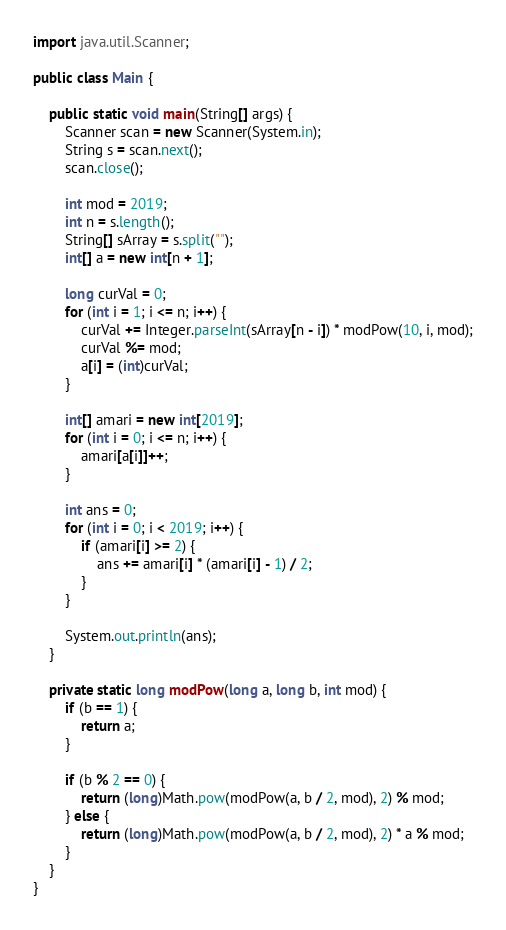Convert code to text. <code><loc_0><loc_0><loc_500><loc_500><_Java_>
import java.util.Scanner;

public class Main {

    public static void main(String[] args) {
        Scanner scan = new Scanner(System.in);
        String s = scan.next();
        scan.close();

        int mod = 2019;
        int n = s.length();
        String[] sArray = s.split("");
        int[] a = new int[n + 1];

        long curVal = 0;
        for (int i = 1; i <= n; i++) {
            curVal += Integer.parseInt(sArray[n - i]) * modPow(10, i, mod);
            curVal %= mod;
            a[i] = (int)curVal;
        }

        int[] amari = new int[2019];
        for (int i = 0; i <= n; i++) {
            amari[a[i]]++;
        }

        int ans = 0;
        for (int i = 0; i < 2019; i++) {
            if (amari[i] >= 2) {
                ans += amari[i] * (amari[i] - 1) / 2;
            }
        }

        System.out.println(ans);
    }

    private static long modPow(long a, long b, int mod) {
        if (b == 1) {
            return a;
        }

        if (b % 2 == 0) {
            return (long)Math.pow(modPow(a, b / 2, mod), 2) % mod;
        } else {
            return (long)Math.pow(modPow(a, b / 2, mod), 2) * a % mod;
        }
    }
}
</code> 